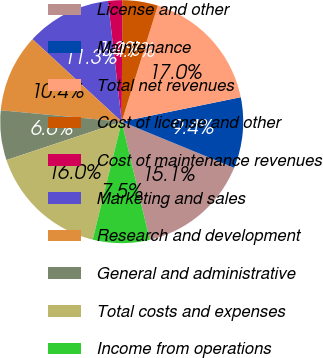Convert chart. <chart><loc_0><loc_0><loc_500><loc_500><pie_chart><fcel>License and other<fcel>Maintenance<fcel>Total net revenues<fcel>Cost of license and other<fcel>Cost of maintenance revenues<fcel>Marketing and sales<fcel>Research and development<fcel>General and administrative<fcel>Total costs and expenses<fcel>Income from operations<nl><fcel>15.09%<fcel>9.43%<fcel>16.98%<fcel>4.72%<fcel>1.89%<fcel>11.32%<fcel>10.38%<fcel>6.61%<fcel>16.04%<fcel>7.55%<nl></chart> 